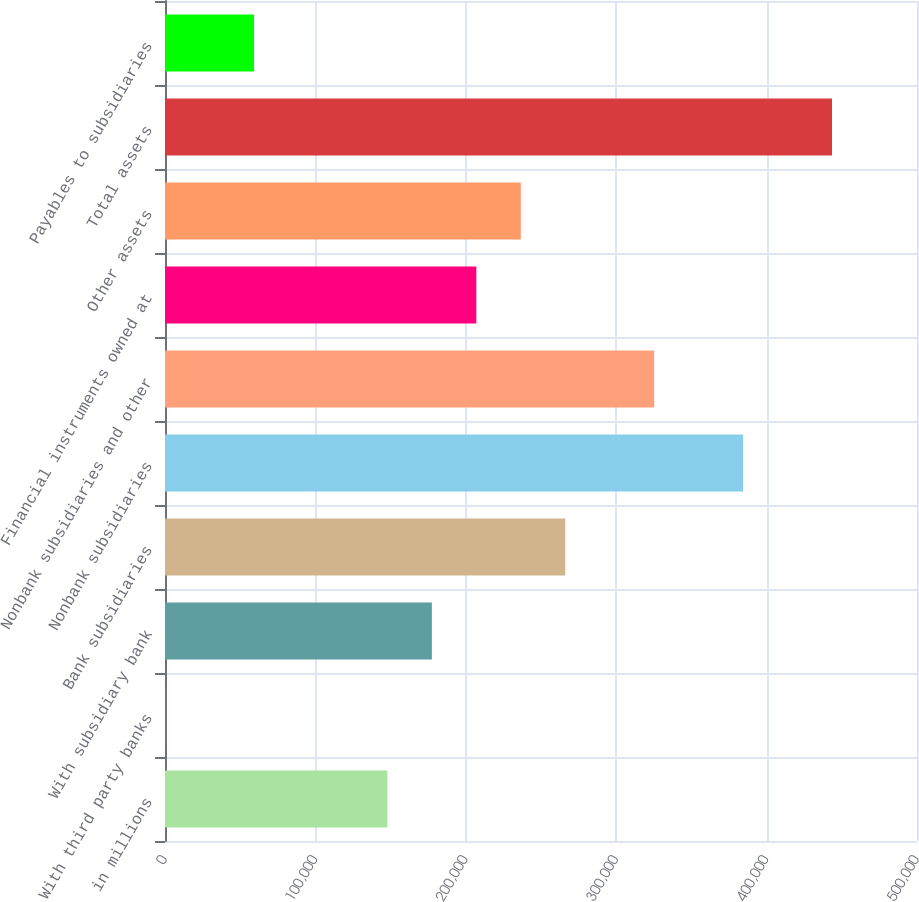Convert chart. <chart><loc_0><loc_0><loc_500><loc_500><bar_chart><fcel>in millions<fcel>With third party banks<fcel>With subsidiary bank<fcel>Bank subsidiaries<fcel>Nonbank subsidiaries<fcel>Nonbank subsidiaries and other<fcel>Financial instruments owned at<fcel>Other assets<fcel>Total assets<fcel>Payables to subsidiaries<nl><fcel>147882<fcel>81<fcel>177442<fcel>266122<fcel>384362<fcel>325242<fcel>207002<fcel>236562<fcel>443482<fcel>59201.2<nl></chart> 